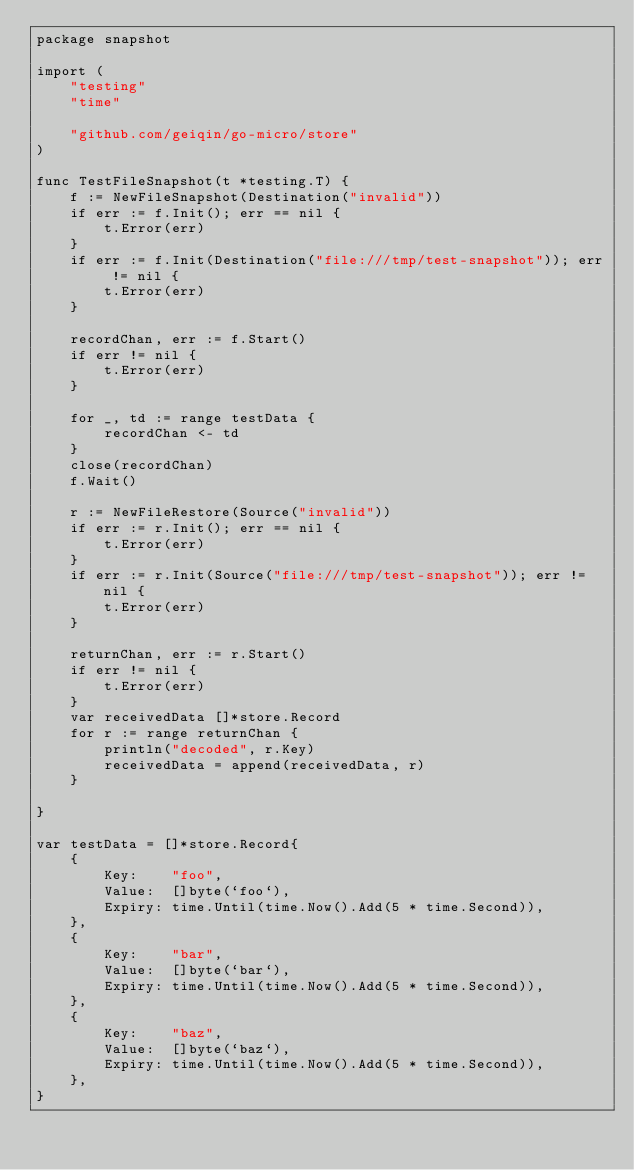<code> <loc_0><loc_0><loc_500><loc_500><_Go_>package snapshot

import (
	"testing"
	"time"

	"github.com/geiqin/go-micro/store"
)

func TestFileSnapshot(t *testing.T) {
	f := NewFileSnapshot(Destination("invalid"))
	if err := f.Init(); err == nil {
		t.Error(err)
	}
	if err := f.Init(Destination("file:///tmp/test-snapshot")); err != nil {
		t.Error(err)
	}

	recordChan, err := f.Start()
	if err != nil {
		t.Error(err)
	}

	for _, td := range testData {
		recordChan <- td
	}
	close(recordChan)
	f.Wait()

	r := NewFileRestore(Source("invalid"))
	if err := r.Init(); err == nil {
		t.Error(err)
	}
	if err := r.Init(Source("file:///tmp/test-snapshot")); err != nil {
		t.Error(err)
	}

	returnChan, err := r.Start()
	if err != nil {
		t.Error(err)
	}
	var receivedData []*store.Record
	for r := range returnChan {
		println("decoded", r.Key)
		receivedData = append(receivedData, r)
	}

}

var testData = []*store.Record{
	{
		Key:    "foo",
		Value:  []byte(`foo`),
		Expiry: time.Until(time.Now().Add(5 * time.Second)),
	},
	{
		Key:    "bar",
		Value:  []byte(`bar`),
		Expiry: time.Until(time.Now().Add(5 * time.Second)),
	},
	{
		Key:    "baz",
		Value:  []byte(`baz`),
		Expiry: time.Until(time.Now().Add(5 * time.Second)),
	},
}
</code> 